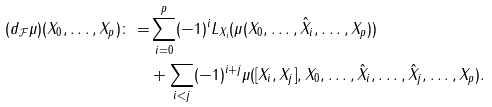<formula> <loc_0><loc_0><loc_500><loc_500>( d _ { \mathcal { F } } \mu ) ( X _ { 0 } , \dots , X _ { p } ) \colon = & \sum _ { i = 0 } ^ { p } ( - 1 ) ^ { i } L _ { X _ { i } } ( \mu ( X _ { 0 } , \dots , \hat { X } _ { i } , \dots , X _ { p } ) ) \\ & + \sum _ { i < j } ( - 1 ) ^ { i + j } \mu ( [ X _ { i } , X _ { j } ] , X _ { 0 } , \dots , \hat { X } _ { i } , \dots , \hat { X } _ { j } , \dots , X _ { p } ) .</formula> 